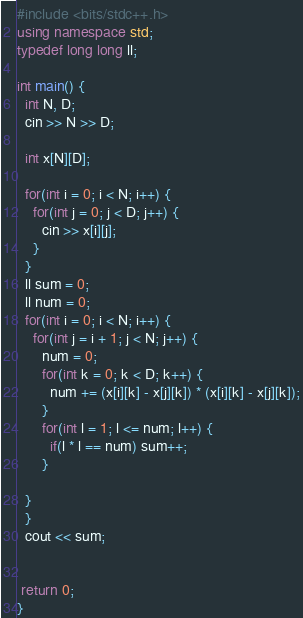<code> <loc_0><loc_0><loc_500><loc_500><_C++_>#include <bits/stdc++.h>
using namespace std;
typedef long long ll;

int main() {
  int N, D;
  cin >> N >> D;

  int x[N][D];

  for(int i = 0; i < N; i++) {
    for(int j = 0; j < D; j++) {
      cin >> x[i][j];
    }
  }
  ll sum = 0;
  ll num = 0;
  for(int i = 0; i < N; i++) {
    for(int j = i + 1; j < N; j++) {
      num = 0;
      for(int k = 0; k < D; k++) {
        num += (x[i][k] - x[j][k]) * (x[i][k] - x[j][k]);
      }
      for(int l = 1; l <= num; l++) {
        if(l * l == num) sum++;
      }

  }
  }
  cout << sum;


 return 0;
}

</code> 